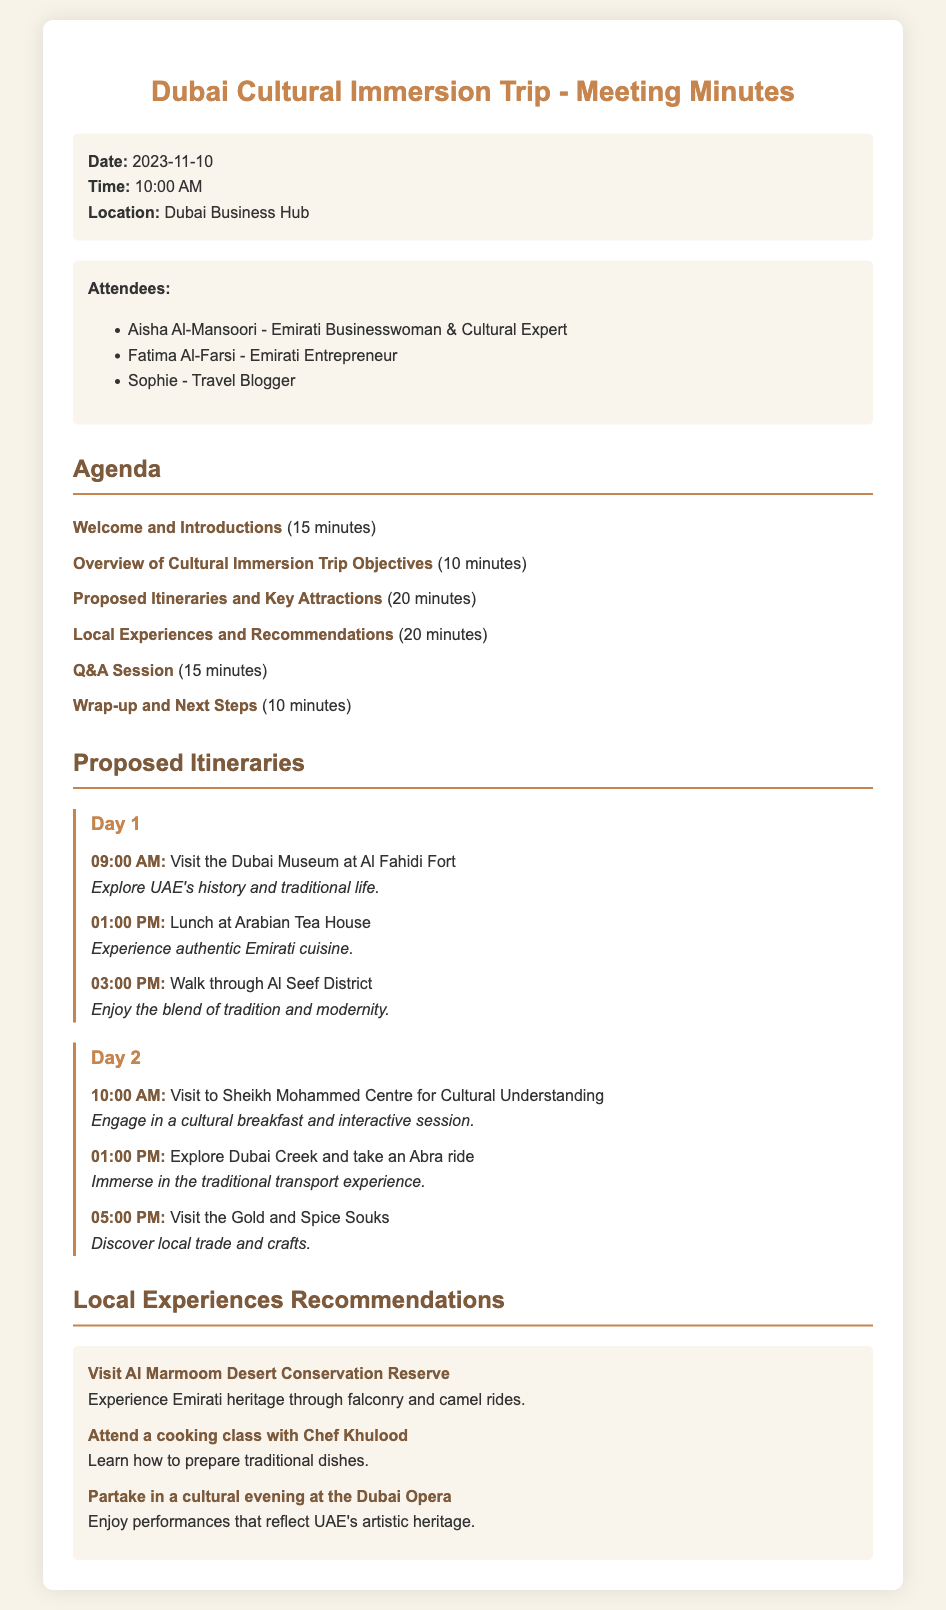What is the date of the meeting? The date of the meeting is mentioned in the meeting details section.
Answer: 2023-11-10 Who is one of the attendees? The attendees list includes names of participants in the meeting.
Answer: Aisha Al-Mansoori How long is the Q&A session? The duration of the Q&A session can be found in the agenda section.
Answer: 15 minutes What is one of the proposed Day 1 activities? The itinerary section outlines specific activities planned for Day 1.
Answer: Visit the Dubai Museum at Al Fahidi Fort What unique experience can be found in the recommendations section? The recommendations section lists special experiences to consider during the trip.
Answer: Visit Al Marmoom Desert Conservation Reserve What time does the Day 2 activities start? The itinerary specifies the start time of activities for Day 2.
Answer: 10:00 AM What is the objective of the cultural immersion trip? The overall objectives can be inferred from the meeting agenda.
Answer: Cultural immersion How many days does the itinerary cover? The proposed itineraries section clearly indicates the number of days the trip entails.
Answer: 2 days 